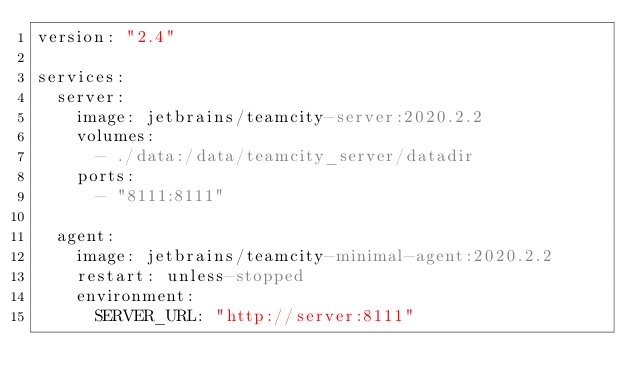Convert code to text. <code><loc_0><loc_0><loc_500><loc_500><_YAML_>version: "2.4"

services:
  server:
    image: jetbrains/teamcity-server:2020.2.2
    volumes:
      - ./data:/data/teamcity_server/datadir
    ports:
      - "8111:8111"

  agent:
    image: jetbrains/teamcity-minimal-agent:2020.2.2
    restart: unless-stopped
    environment:
      SERVER_URL: "http://server:8111"
</code> 